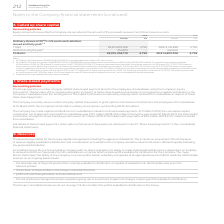From Vodafone Group Plc's financial document, Which financial years' information is shown in the table? The document shows two values: 2018 and 2019. From the document: "2019 2018 2019 2018..." Also, How many shares were allotted as at 31 March 2019? According to the financial document, 28,815,258,178. The relevant text states: "ed during the year 3 454,870 – 660,460 – 31 March 28,815,258,178 4,796 28,814,803,308 4,796..." Also, How many shares were allotted as at 31 March 2018? According to the financial document, 28,814,803,308. The relevant text states: "1 April 28,814,803,308 4,796 28,814,142,848 4,796 Allotted during the year 3 454,870 – 660,460 – 31 March 28,815,258,178 4..." Also, can you calculate: What is the 2019 average amount of ordinary shares as at 1 April? To answer this question, I need to perform calculations using the financial data. The calculation is: (28,814,803,308+28,814,142,848)/2, which equals 28814473078. This is based on the information: "1 April 28,814,803,308 4,796 28,814,142,848 4,796 Allotted during the year 3 454,870 – 660,460 – 31 March 28,815,258,178 4 1 April 28,814,803,308 4,796 28,814,142,848 4,796 Allotted during the year 3 ..." The key data points involved are: 28,814,142,848, 28,814,803,308. Also, can you calculate: What is the 2019 average amount of ordinary shares as at 31 March? To answer this question, I need to perform calculations using the financial data. The calculation is: (28,815,258,178+28,814,803,308)/2, which equals 28815030743. This is based on the information: "1 April 28,814,803,308 4,796 28,814,142,848 4,796 Allotted during the year 3 454,870 – 660,460 – 31 March 28,815,258,178 4 ed during the year 3 454,870 – 660,460 – 31 March 28,815,258,178 4,796 28,814..." The key data points involved are: 28,814,803,308, 28,815,258,178. Also, can you calculate: What is the 2019 average amount of ordinary shares allotted during the year? To answer this question, I need to perform calculations using the financial data. The calculation is: (454,870+660,460)/2, which equals 557665. This is based on the information: "42,848 4,796 Allotted during the year 3 454,870 – 660,460 – 31 March 28,815,258,178 4,796 28,814,803,308 4,796 6 28,814,142,848 4,796 Allotted during the year 3 454,870 – 660,460 – 31 March 28,815,258..." The key data points involved are: 454,870, 660,460. 